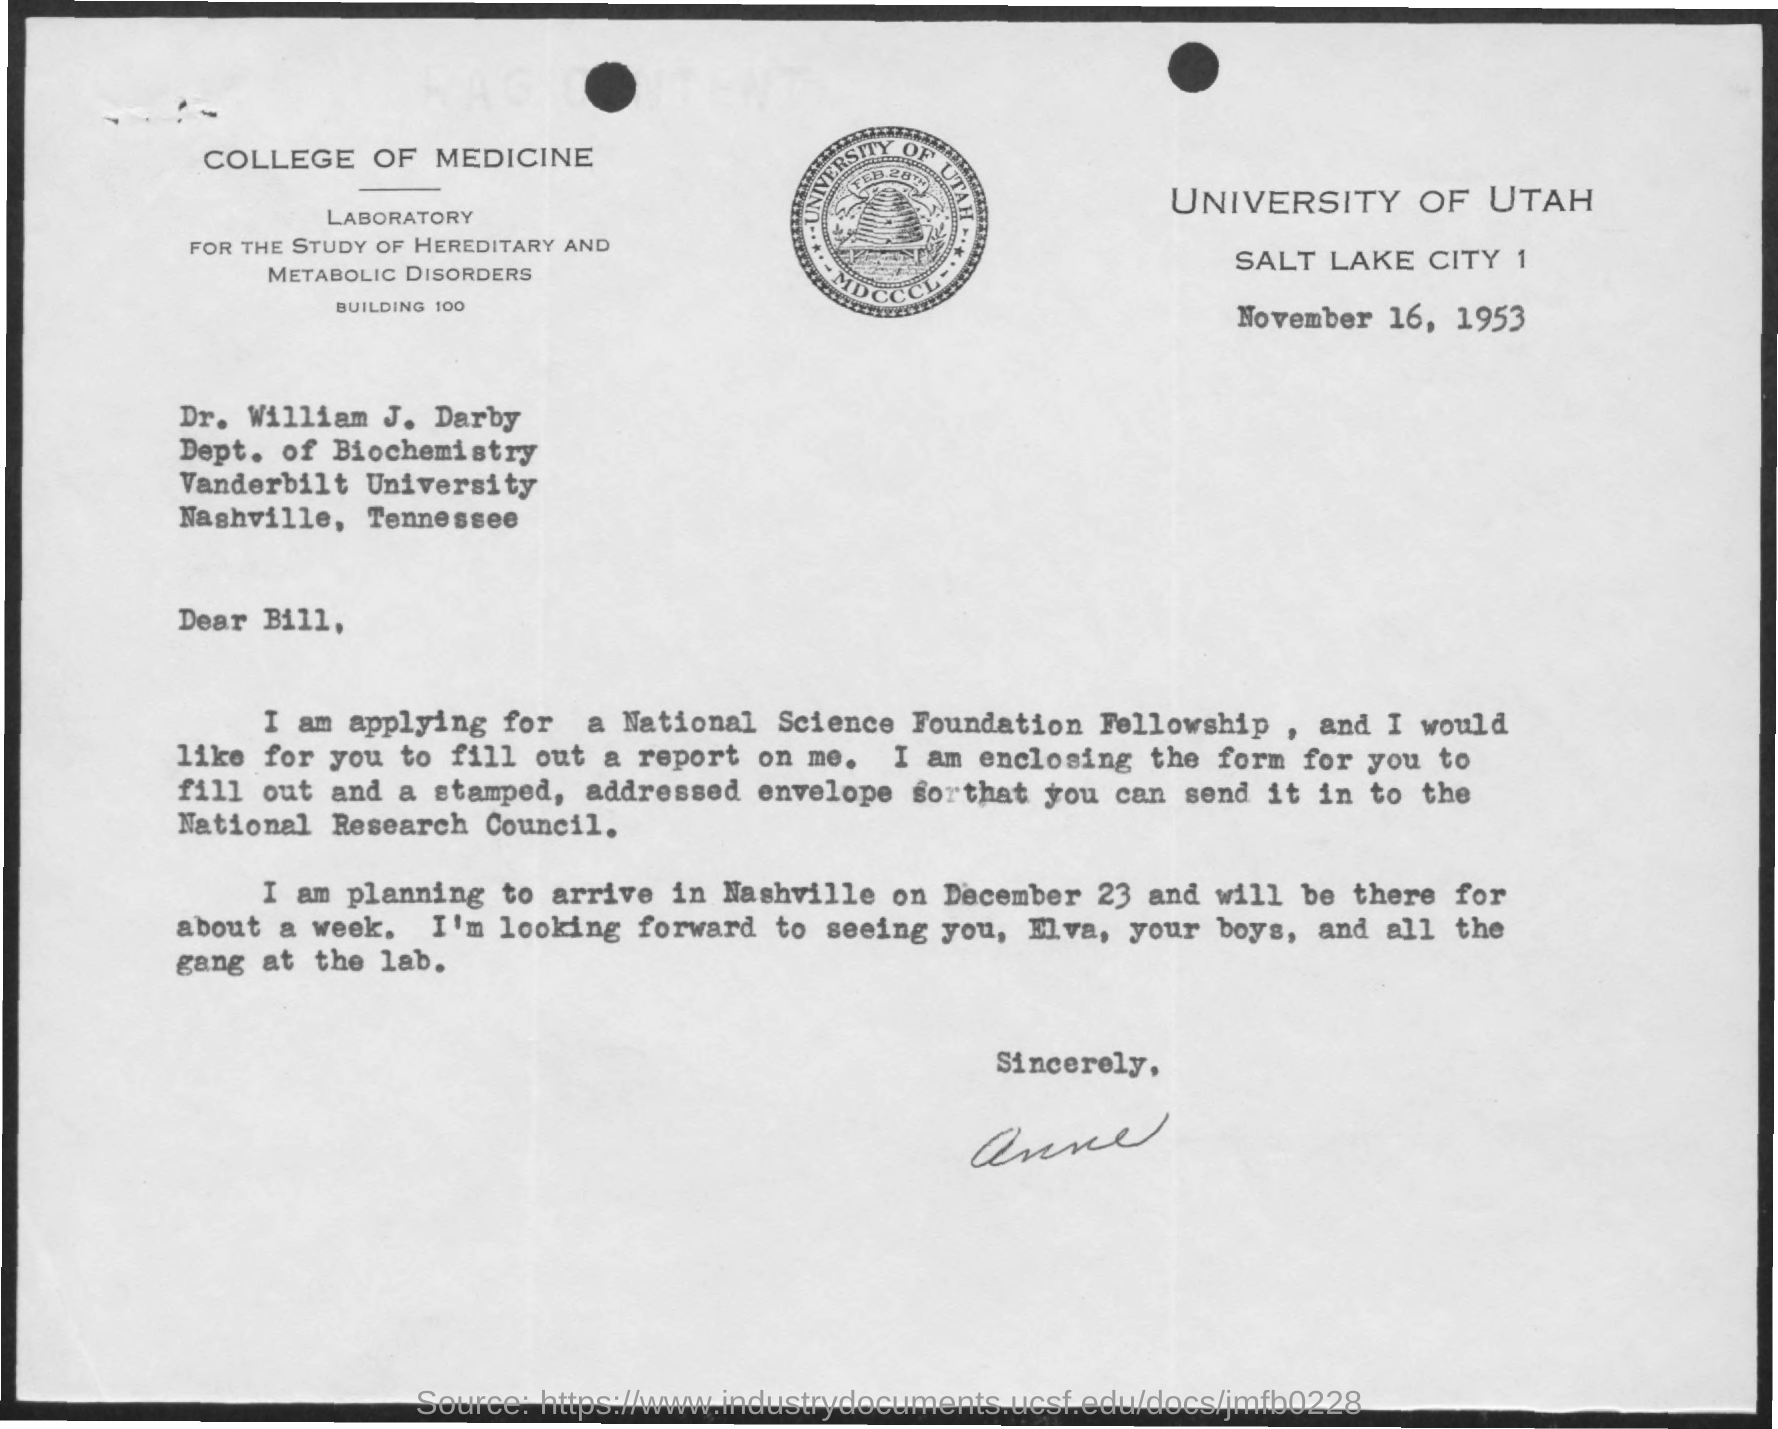Which University is mentioned in the letterhead?
Your response must be concise. UNIVERSITY OF UTAH. What is the issued date of this letter?
Offer a very short reply. November 16, 1953. Who is the addressee of this letter?
Give a very brief answer. Dr. William J. Darby. 